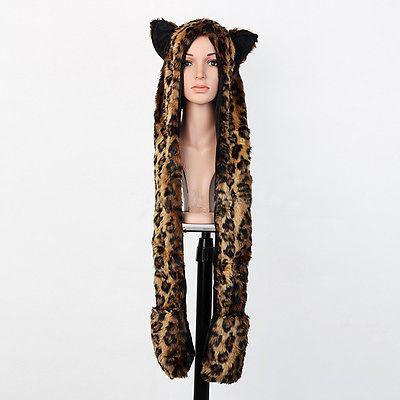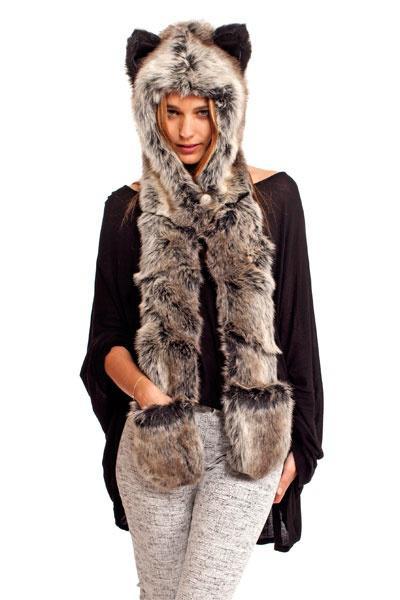The first image is the image on the left, the second image is the image on the right. For the images displayed, is the sentence "a person has one hand tucked in a hat pocket" factually correct? Answer yes or no. Yes. The first image is the image on the left, the second image is the image on the right. Considering the images on both sides, is "At least one of the hats has a giraffe print." valid? Answer yes or no. No. 